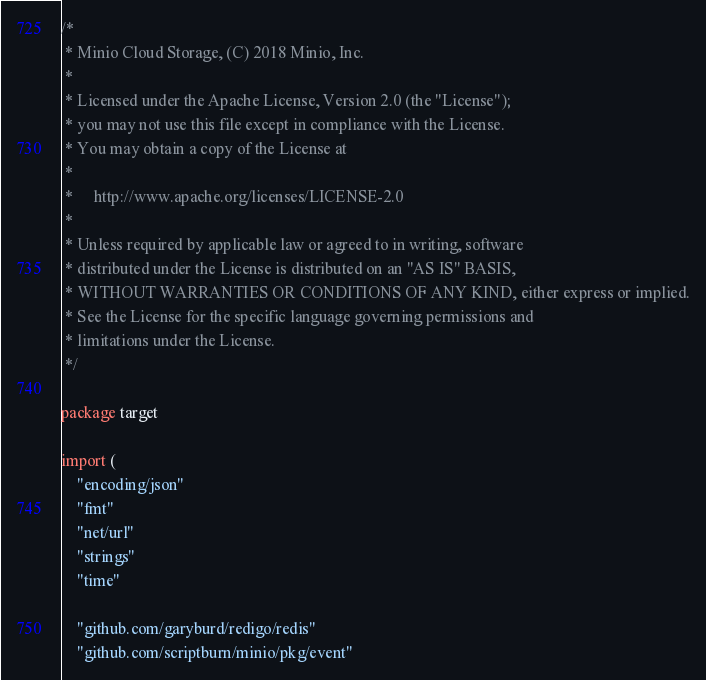<code> <loc_0><loc_0><loc_500><loc_500><_Go_>/*
 * Minio Cloud Storage, (C) 2018 Minio, Inc.
 *
 * Licensed under the Apache License, Version 2.0 (the "License");
 * you may not use this file except in compliance with the License.
 * You may obtain a copy of the License at
 *
 *     http://www.apache.org/licenses/LICENSE-2.0
 *
 * Unless required by applicable law or agreed to in writing, software
 * distributed under the License is distributed on an "AS IS" BASIS,
 * WITHOUT WARRANTIES OR CONDITIONS OF ANY KIND, either express or implied.
 * See the License for the specific language governing permissions and
 * limitations under the License.
 */

package target

import (
	"encoding/json"
	"fmt"
	"net/url"
	"strings"
	"time"

	"github.com/garyburd/redigo/redis"
	"github.com/scriptburn/minio/pkg/event"</code> 